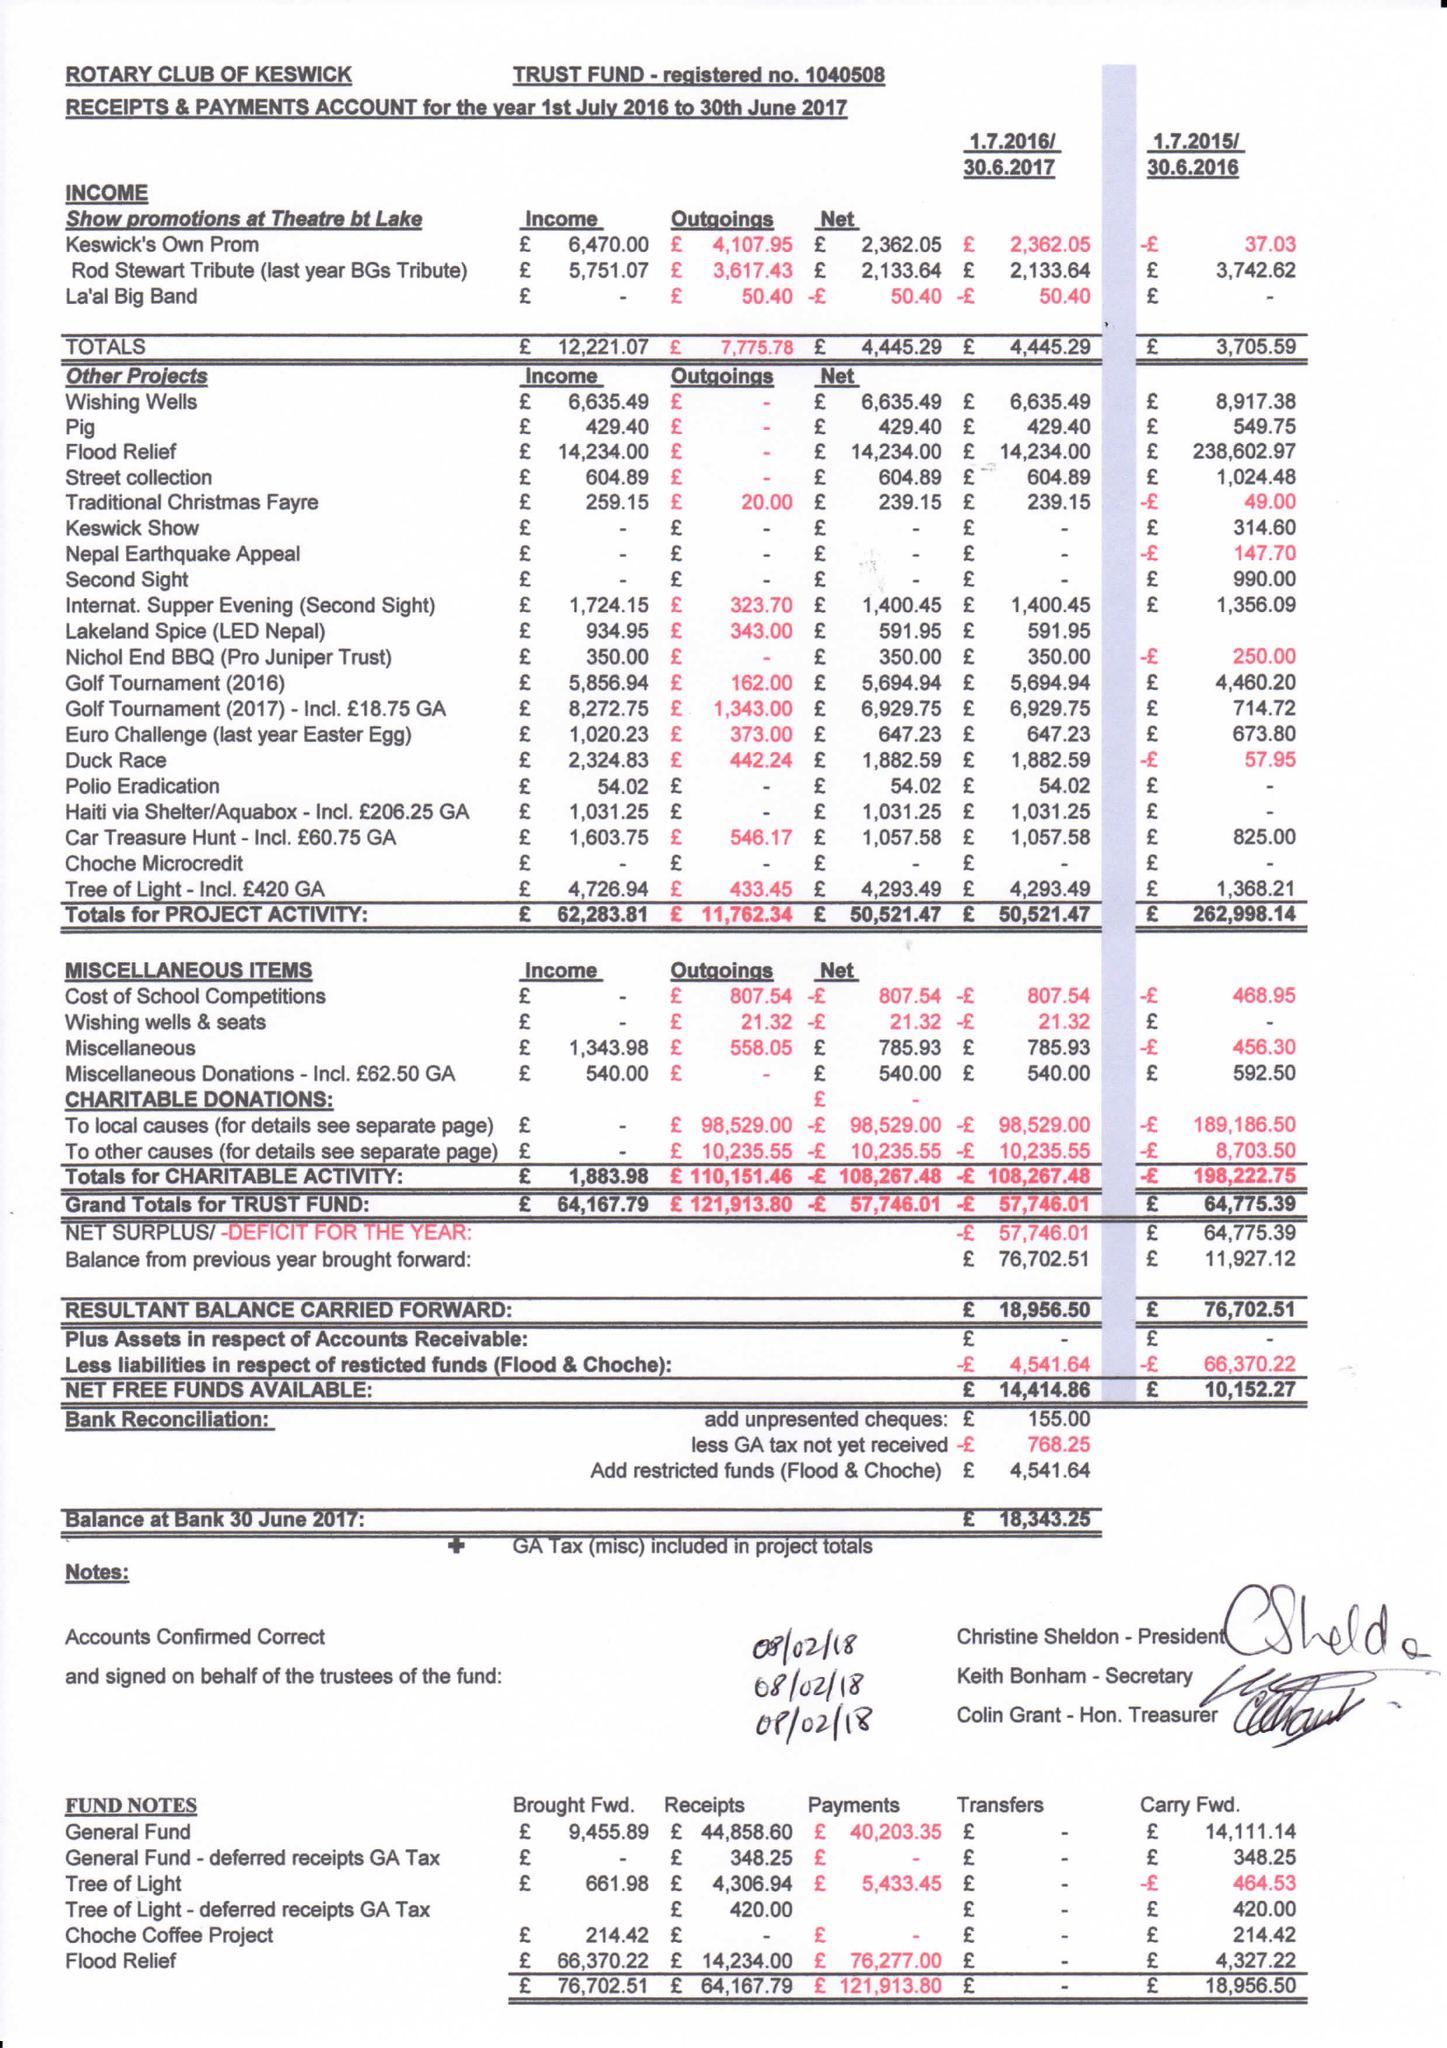What is the value for the charity_number?
Answer the question using a single word or phrase. 1040508 